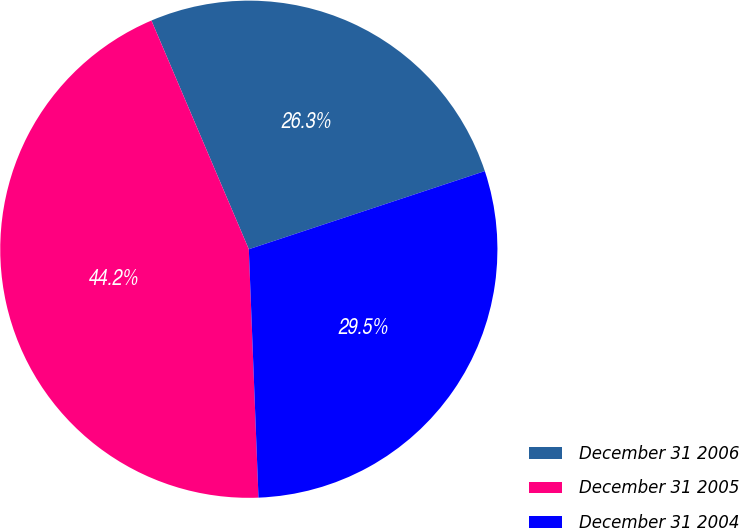Convert chart to OTSL. <chart><loc_0><loc_0><loc_500><loc_500><pie_chart><fcel>December 31 2006<fcel>December 31 2005<fcel>December 31 2004<nl><fcel>26.32%<fcel>44.21%<fcel>29.47%<nl></chart> 